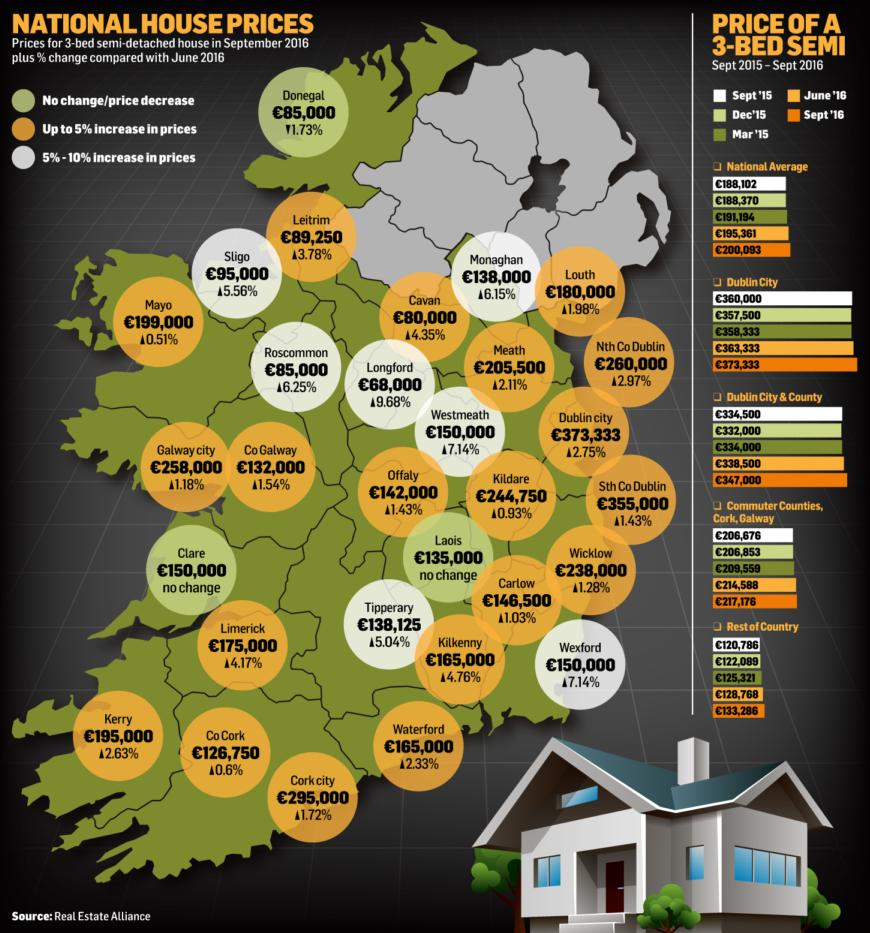Identify some key points in this picture. In September 2016, Dublin City had the highest house prices compared to other cities. The city of Donegal was the only one that showed a decrease in house prices in September 2016. Longford was the city with the lowest house prices in September 2016. The increase in house prices in Sligo since June 2016 is 5.56%. The price of a house in Dublin City is significantly higher than in Longford, with a difference of €305,333. 